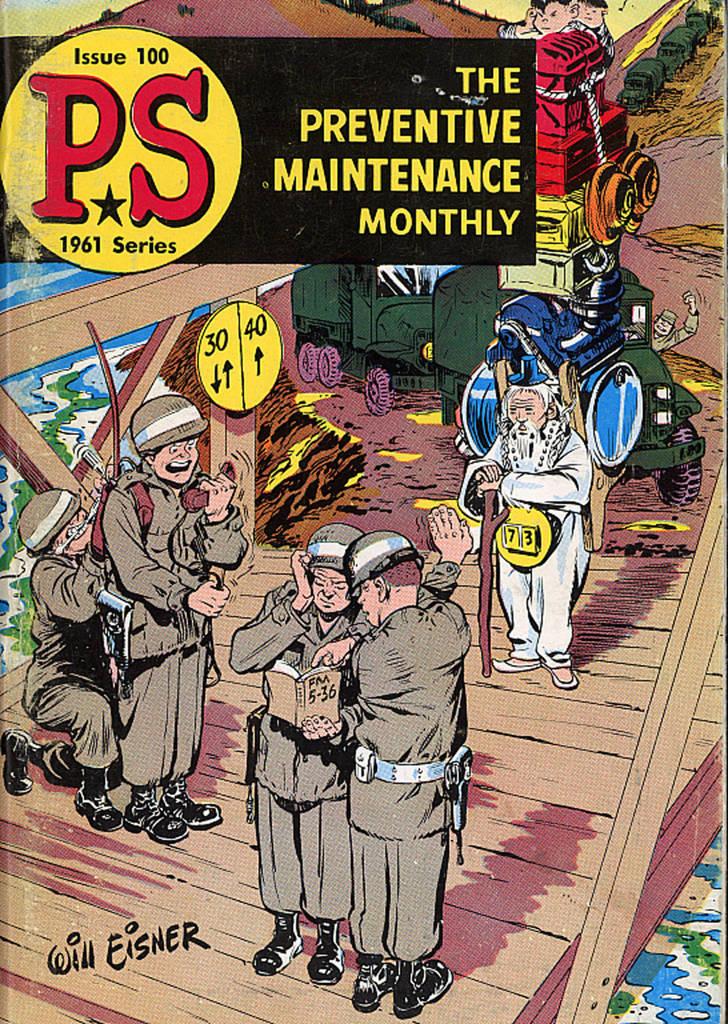What comic is this?
Keep it short and to the point. The preventive maintenance monthly. What year was this published?
Your answer should be compact. 1961. 